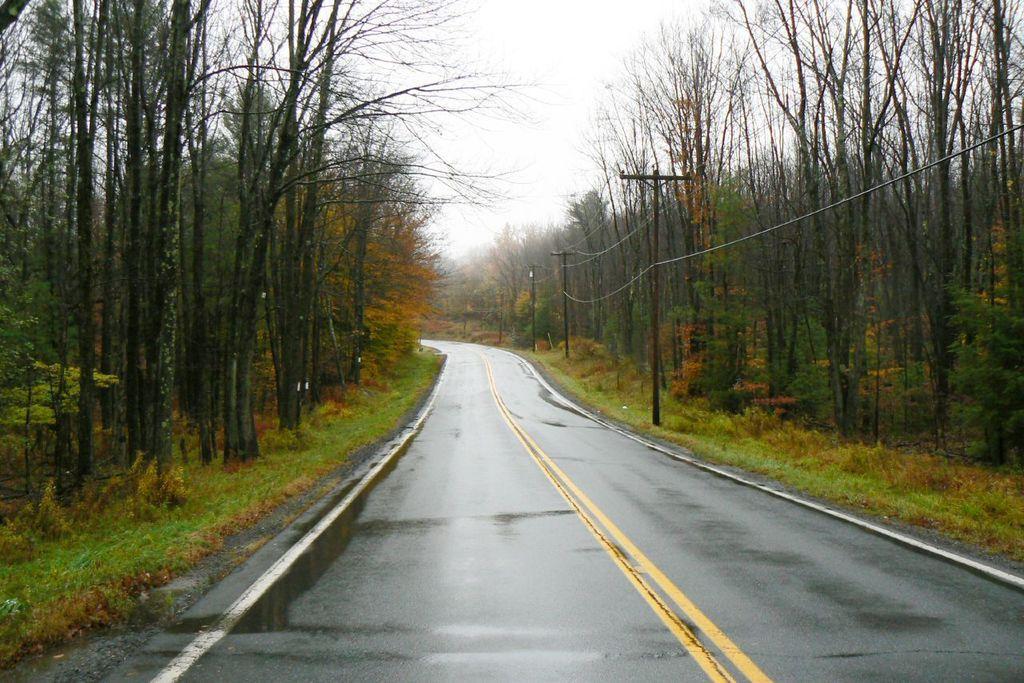Describe this image in one or two sentences. In this image I see the road on which there is water and I see number of poles and wires on it and I see number of trees and I see the grass. In the background I see the sky. 